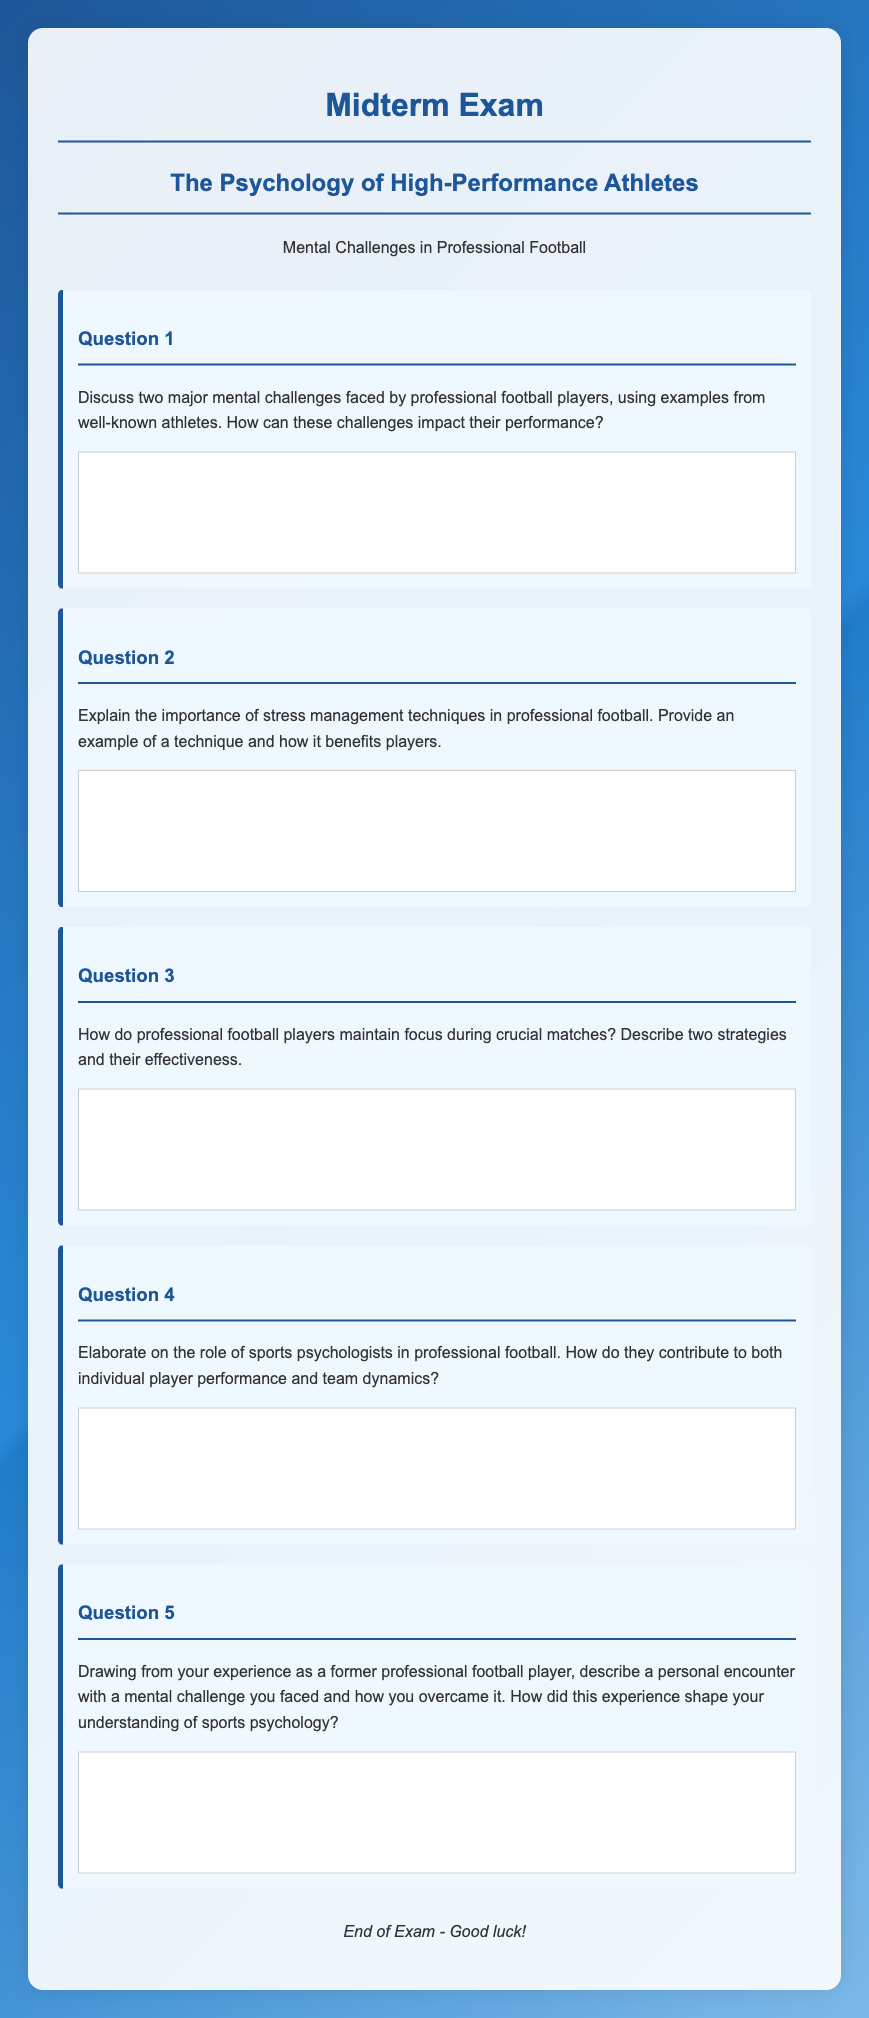What is the title of the midterm exam? The title of the midterm exam is presented in the header of the document.
Answer: The Psychology of High-Performance Athletes How many questions are included in the exam? The number of questions can be found by counting the instances of "Question" in the document.
Answer: Five Which question asks about stress management techniques? The question in the document related to stress management techniques is clearly numbered.
Answer: Question 2 What is the focus of Question 5? The focus of Question 5 is based on personal experience, as described in its phrasing.
Answer: Personal encounter with a mental challenge What color is the background gradient of the document? The color details are mentioned in the style section of the document, describing the background gradient.
Answer: Blue How are the questions formatted in the document? The formatting style for questions is specified and characterized by specific background color and style in the document.
Answer: Question headers with a background color and margin settings What is the main theme of the midterm exam? The theme can be identified from the title and the introductory description in the document.
Answer: The Psychology of High-Performance Athletes What is the purpose of the footer in the document? The footer serves a specific function at the end of the document as part of its structure.
Answer: To conclude the exam and wish good luck 